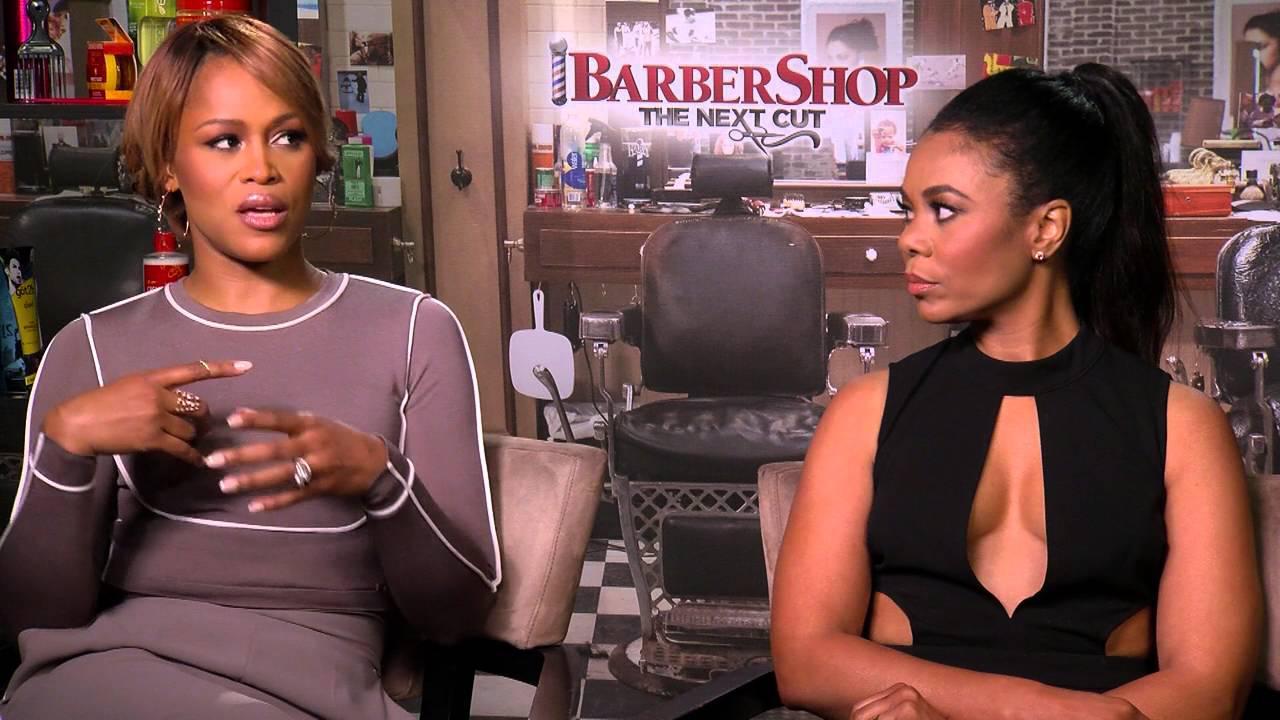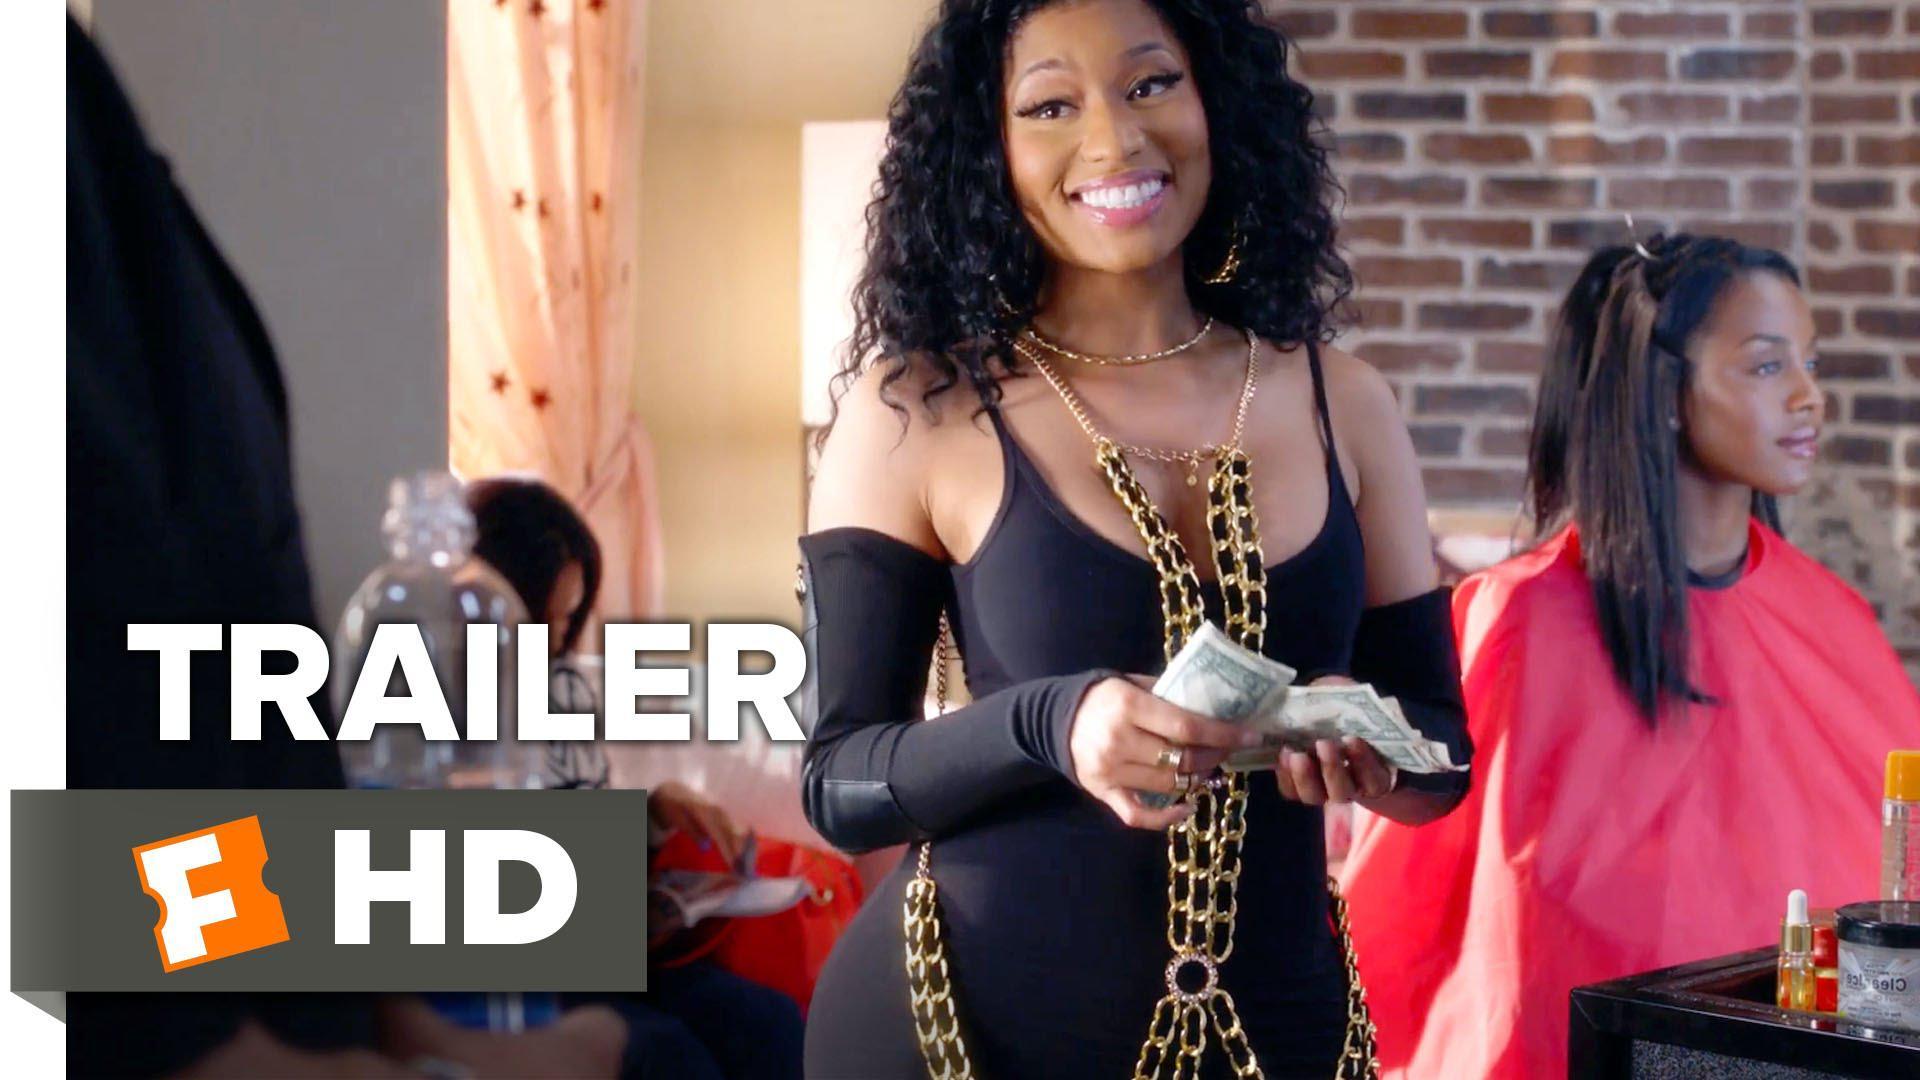The first image is the image on the left, the second image is the image on the right. Considering the images on both sides, is "None of the women in the pictures have blue hair." valid? Answer yes or no. Yes. The first image is the image on the left, the second image is the image on the right. Given the left and right images, does the statement "An image shows a woman in a printed top standing behind a customer in a red smock." hold true? Answer yes or no. No. 